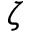Convert formula to latex. <formula><loc_0><loc_0><loc_500><loc_500>\zeta</formula> 